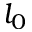Convert formula to latex. <formula><loc_0><loc_0><loc_500><loc_500>l _ { 0 }</formula> 